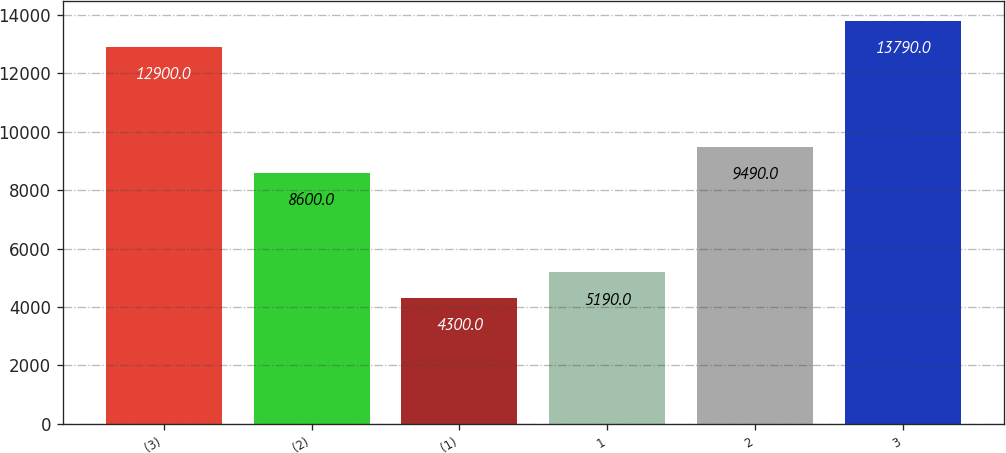<chart> <loc_0><loc_0><loc_500><loc_500><bar_chart><fcel>(3)<fcel>(2)<fcel>(1)<fcel>1<fcel>2<fcel>3<nl><fcel>12900<fcel>8600<fcel>4300<fcel>5190<fcel>9490<fcel>13790<nl></chart> 